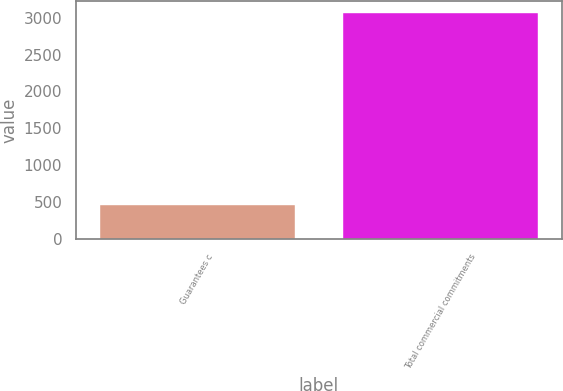Convert chart. <chart><loc_0><loc_0><loc_500><loc_500><bar_chart><fcel>Guarantees c<fcel>Total commercial commitments<nl><fcel>465<fcel>3067<nl></chart> 